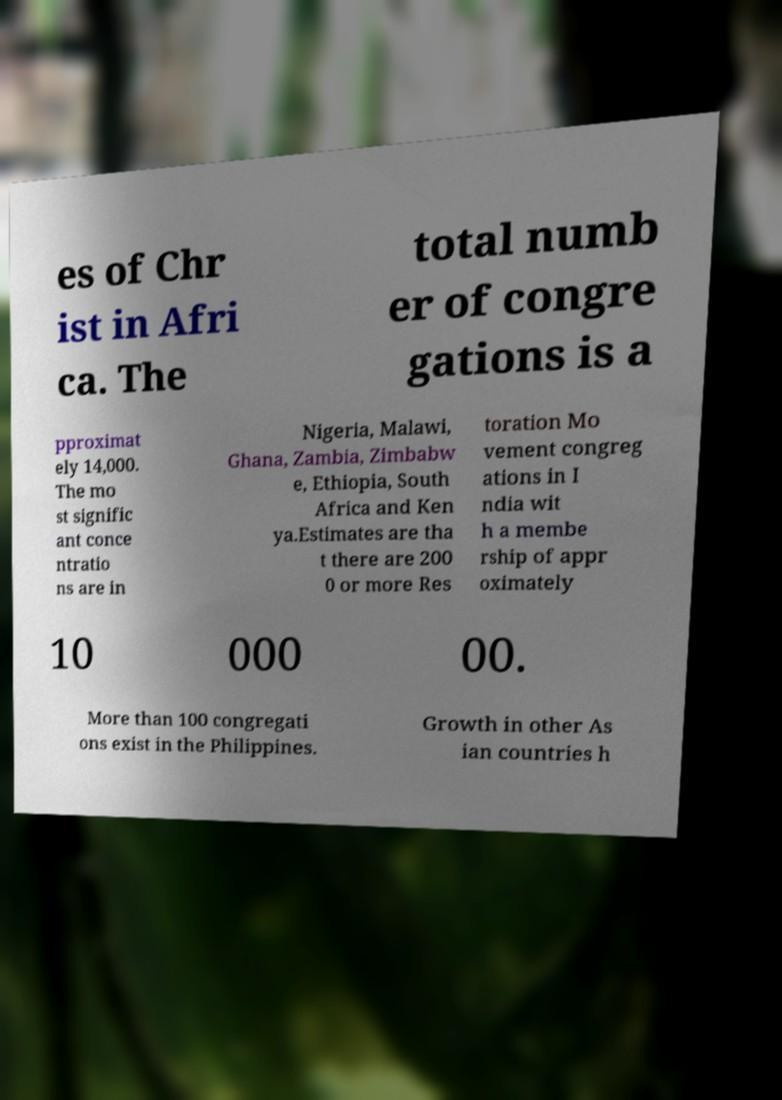What messages or text are displayed in this image? I need them in a readable, typed format. es of Chr ist in Afri ca. The total numb er of congre gations is a pproximat ely 14,000. The mo st signific ant conce ntratio ns are in Nigeria, Malawi, Ghana, Zambia, Zimbabw e, Ethiopia, South Africa and Ken ya.Estimates are tha t there are 200 0 or more Res toration Mo vement congreg ations in I ndia wit h a membe rship of appr oximately 10 000 00. More than 100 congregati ons exist in the Philippines. Growth in other As ian countries h 